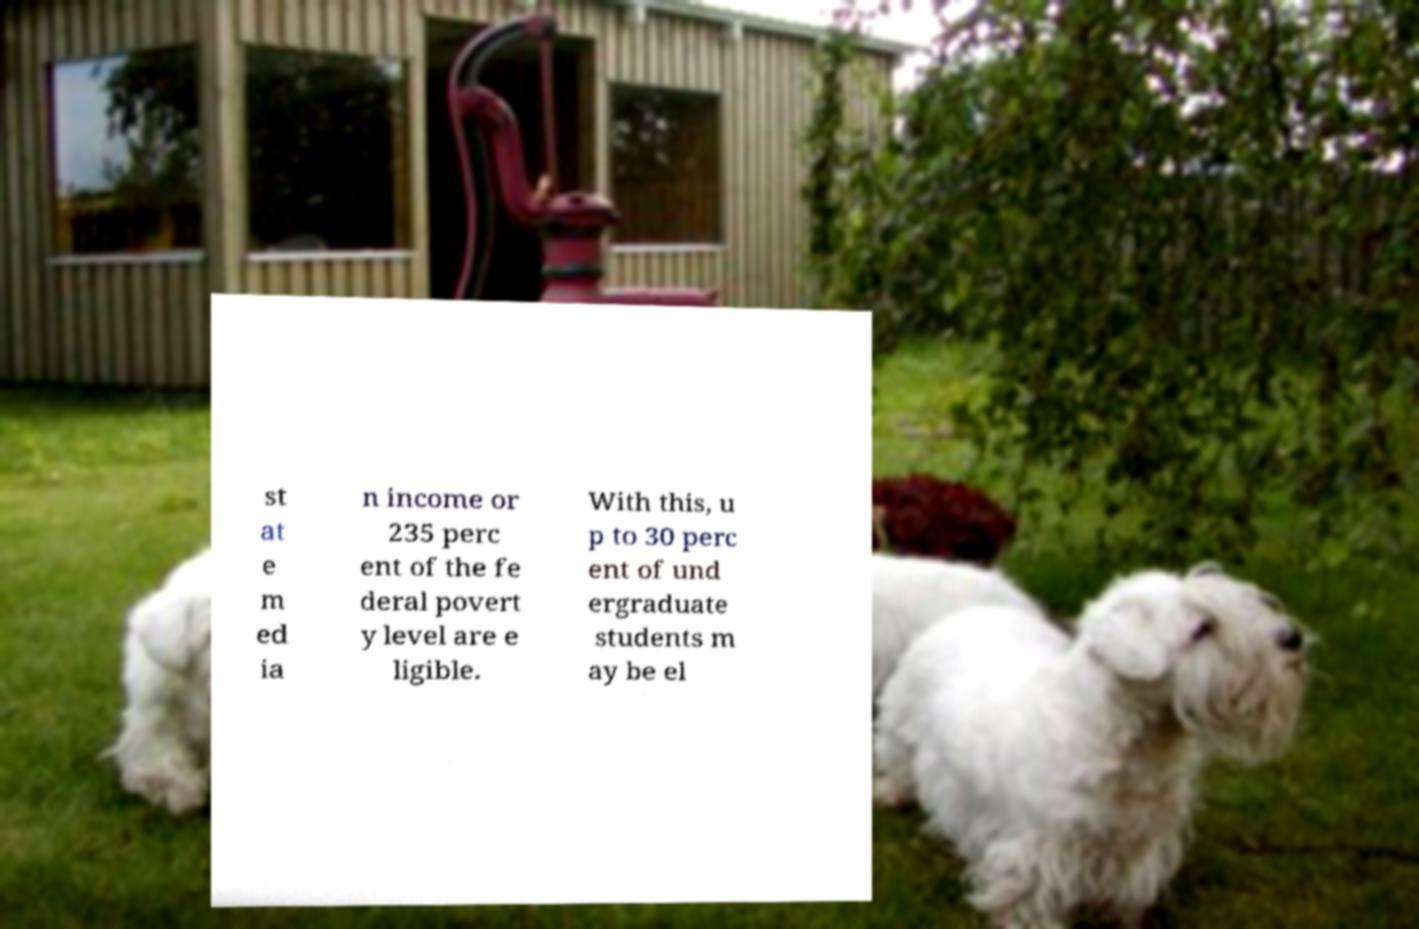Please read and relay the text visible in this image. What does it say? st at e m ed ia n income or 235 perc ent of the fe deral povert y level are e ligible. With this, u p to 30 perc ent of und ergraduate students m ay be el 